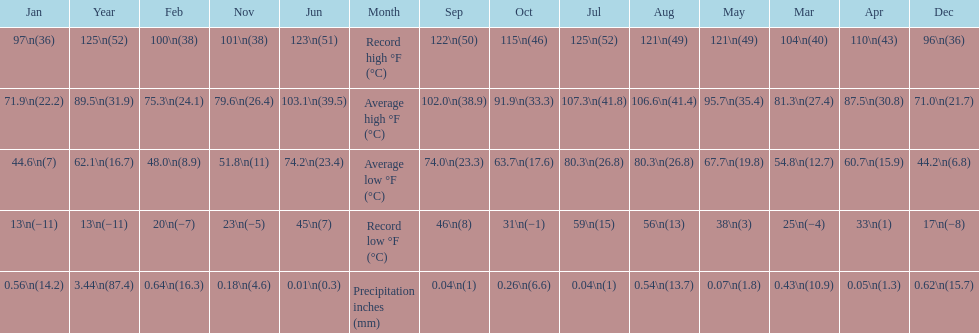How many months saw record lows below freezing? 7. 